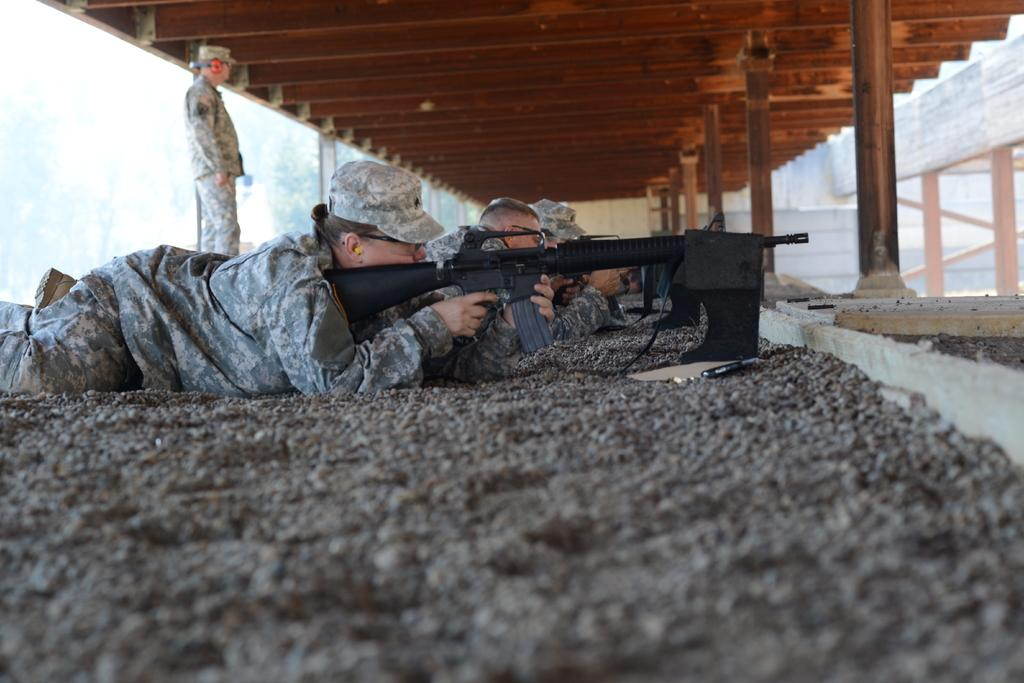Who or what is present in the image? There are people in the image. What are the people doing in the image? The people are lying on the ground. What objects are the people holding in the image? The people are holding guns. What type of planes can be seen flying over the border in the image? There are no planes or borders present in the image; it only features people lying on the ground and holding guns. 